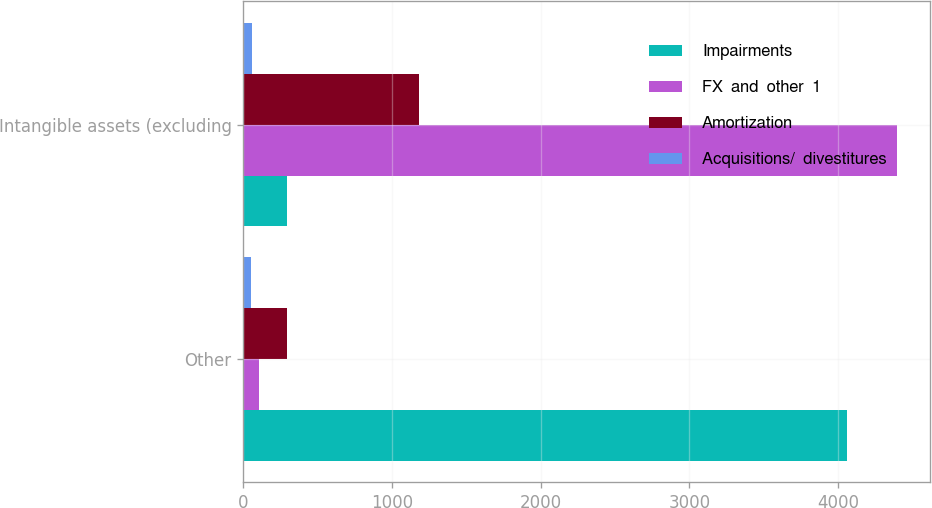<chart> <loc_0><loc_0><loc_500><loc_500><stacked_bar_chart><ecel><fcel>Other<fcel>Intangible assets (excluding<nl><fcel>Impairments<fcel>4058<fcel>292<nl><fcel>FX  and  other  1<fcel>108<fcel>4400<nl><fcel>Amortization<fcel>292<fcel>1179<nl><fcel>Acquisitions/  divestitures<fcel>53<fcel>56<nl></chart> 